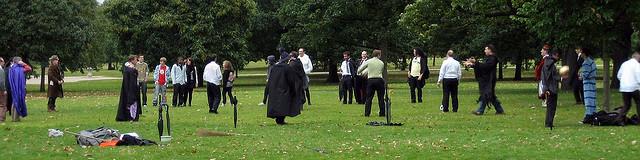What color are the umbrellas?
Answer briefly. Black. What type of tree are they standing in front of?
Answer briefly. Oak. What are surrounding the people?
Short answer required. Trees. What event is happening?
Concise answer only. Graduation. Are they wearing costumes?
Give a very brief answer. Yes. 